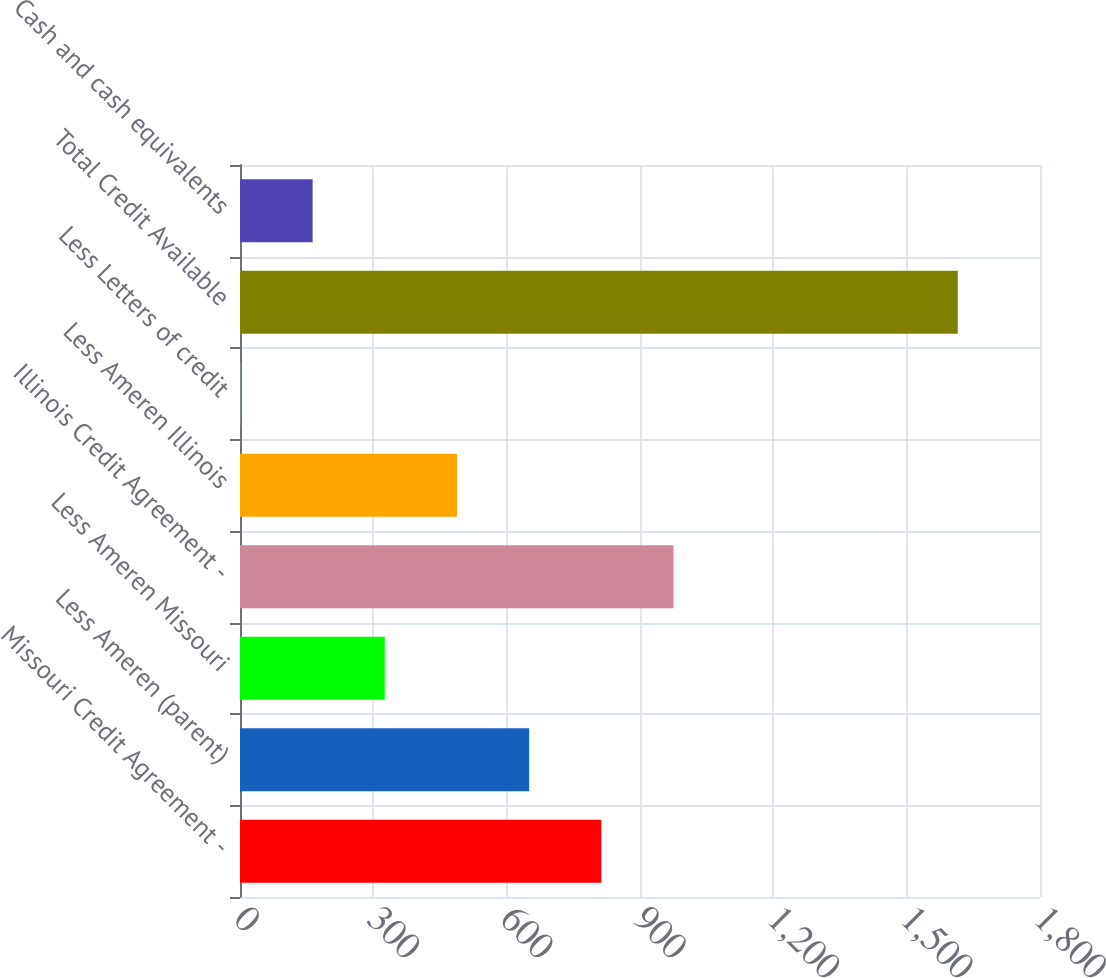Convert chart to OTSL. <chart><loc_0><loc_0><loc_500><loc_500><bar_chart><fcel>Missouri Credit Agreement -<fcel>Less Ameren (parent)<fcel>Less Ameren Missouri<fcel>Illinois Credit Agreement -<fcel>Less Ameren Illinois<fcel>Less Letters of credit<fcel>Total Credit Available<fcel>Cash and cash equivalents<nl><fcel>813<fcel>650.6<fcel>325.8<fcel>975.4<fcel>488.2<fcel>1<fcel>1615<fcel>163.4<nl></chart> 